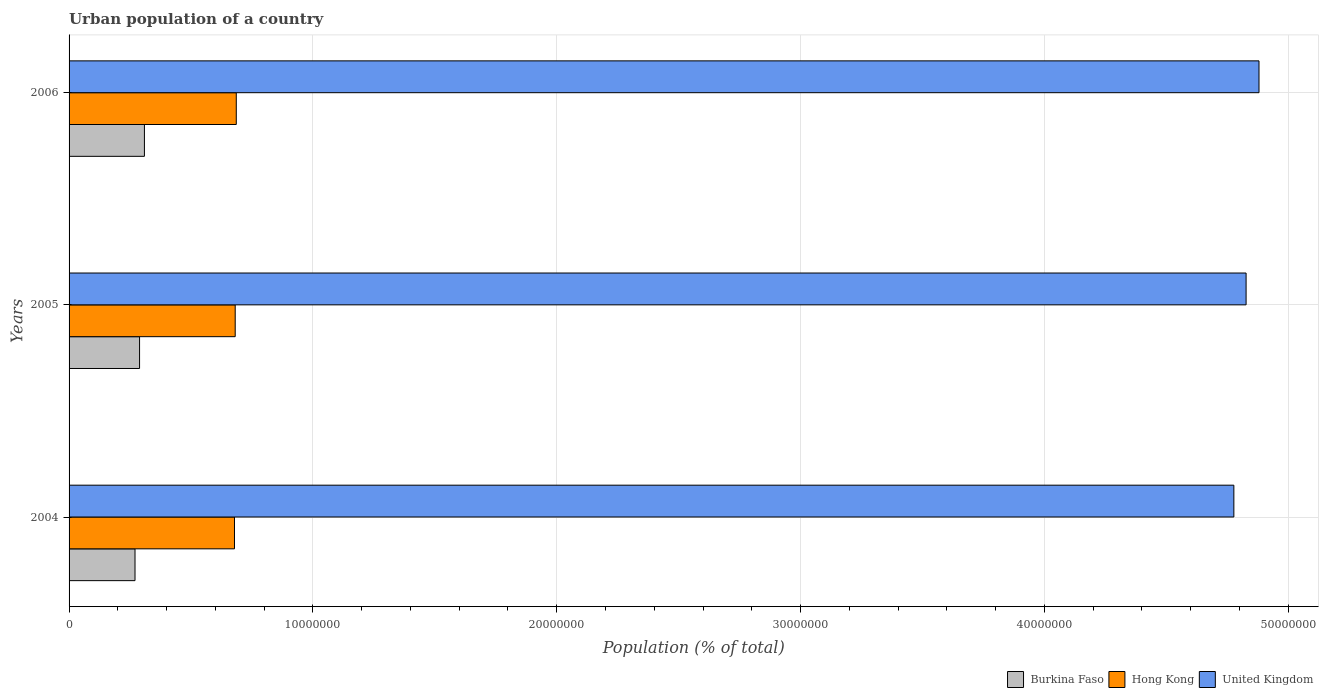How many bars are there on the 2nd tick from the top?
Ensure brevity in your answer.  3. What is the label of the 3rd group of bars from the top?
Offer a terse response. 2004. In how many cases, is the number of bars for a given year not equal to the number of legend labels?
Your response must be concise. 0. What is the urban population in United Kingdom in 2005?
Give a very brief answer. 4.83e+07. Across all years, what is the maximum urban population in Hong Kong?
Provide a short and direct response. 6.86e+06. Across all years, what is the minimum urban population in United Kingdom?
Keep it short and to the point. 4.78e+07. What is the total urban population in Hong Kong in the graph?
Provide a succinct answer. 2.05e+07. What is the difference between the urban population in Burkina Faso in 2005 and that in 2006?
Ensure brevity in your answer.  -2.00e+05. What is the difference between the urban population in United Kingdom in 2004 and the urban population in Burkina Faso in 2005?
Your answer should be compact. 4.49e+07. What is the average urban population in Hong Kong per year?
Your answer should be very brief. 6.82e+06. In the year 2004, what is the difference between the urban population in United Kingdom and urban population in Burkina Faso?
Make the answer very short. 4.51e+07. In how many years, is the urban population in Burkina Faso greater than 32000000 %?
Provide a short and direct response. 0. What is the ratio of the urban population in Hong Kong in 2005 to that in 2006?
Your answer should be compact. 0.99. Is the difference between the urban population in United Kingdom in 2004 and 2006 greater than the difference between the urban population in Burkina Faso in 2004 and 2006?
Provide a short and direct response. No. What is the difference between the highest and the second highest urban population in Burkina Faso?
Provide a short and direct response. 2.00e+05. What is the difference between the highest and the lowest urban population in Hong Kong?
Make the answer very short. 7.36e+04. In how many years, is the urban population in Burkina Faso greater than the average urban population in Burkina Faso taken over all years?
Give a very brief answer. 1. Is the sum of the urban population in Hong Kong in 2004 and 2005 greater than the maximum urban population in United Kingdom across all years?
Offer a terse response. No. What does the 3rd bar from the top in 2005 represents?
Ensure brevity in your answer.  Burkina Faso. What does the 1st bar from the bottom in 2004 represents?
Ensure brevity in your answer.  Burkina Faso. How many bars are there?
Provide a succinct answer. 9. What is the difference between two consecutive major ticks on the X-axis?
Ensure brevity in your answer.  1.00e+07. Are the values on the major ticks of X-axis written in scientific E-notation?
Keep it short and to the point. No. Does the graph contain grids?
Make the answer very short. Yes. How many legend labels are there?
Keep it short and to the point. 3. What is the title of the graph?
Give a very brief answer. Urban population of a country. Does "Iraq" appear as one of the legend labels in the graph?
Your answer should be very brief. No. What is the label or title of the X-axis?
Your answer should be compact. Population (% of total). What is the label or title of the Y-axis?
Offer a terse response. Years. What is the Population (% of total) of Burkina Faso in 2004?
Offer a very short reply. 2.70e+06. What is the Population (% of total) of Hong Kong in 2004?
Provide a short and direct response. 6.78e+06. What is the Population (% of total) in United Kingdom in 2004?
Offer a very short reply. 4.78e+07. What is the Population (% of total) of Burkina Faso in 2005?
Offer a very short reply. 2.89e+06. What is the Population (% of total) in Hong Kong in 2005?
Offer a terse response. 6.81e+06. What is the Population (% of total) of United Kingdom in 2005?
Make the answer very short. 4.83e+07. What is the Population (% of total) of Burkina Faso in 2006?
Your answer should be very brief. 3.09e+06. What is the Population (% of total) in Hong Kong in 2006?
Ensure brevity in your answer.  6.86e+06. What is the Population (% of total) of United Kingdom in 2006?
Provide a short and direct response. 4.88e+07. Across all years, what is the maximum Population (% of total) of Burkina Faso?
Provide a short and direct response. 3.09e+06. Across all years, what is the maximum Population (% of total) in Hong Kong?
Offer a terse response. 6.86e+06. Across all years, what is the maximum Population (% of total) of United Kingdom?
Offer a very short reply. 4.88e+07. Across all years, what is the minimum Population (% of total) of Burkina Faso?
Make the answer very short. 2.70e+06. Across all years, what is the minimum Population (% of total) in Hong Kong?
Make the answer very short. 6.78e+06. Across all years, what is the minimum Population (% of total) of United Kingdom?
Make the answer very short. 4.78e+07. What is the total Population (% of total) in Burkina Faso in the graph?
Offer a very short reply. 8.69e+06. What is the total Population (% of total) in Hong Kong in the graph?
Your answer should be very brief. 2.05e+07. What is the total Population (% of total) of United Kingdom in the graph?
Your answer should be compact. 1.45e+08. What is the difference between the Population (% of total) in Burkina Faso in 2004 and that in 2005?
Provide a short and direct response. -1.86e+05. What is the difference between the Population (% of total) in Hong Kong in 2004 and that in 2005?
Ensure brevity in your answer.  -2.97e+04. What is the difference between the Population (% of total) of United Kingdom in 2004 and that in 2005?
Your answer should be very brief. -5.02e+05. What is the difference between the Population (% of total) in Burkina Faso in 2004 and that in 2006?
Your answer should be compact. -3.86e+05. What is the difference between the Population (% of total) in Hong Kong in 2004 and that in 2006?
Your answer should be compact. -7.36e+04. What is the difference between the Population (% of total) in United Kingdom in 2004 and that in 2006?
Provide a succinct answer. -1.03e+06. What is the difference between the Population (% of total) of Burkina Faso in 2005 and that in 2006?
Provide a succinct answer. -2.00e+05. What is the difference between the Population (% of total) in Hong Kong in 2005 and that in 2006?
Give a very brief answer. -4.39e+04. What is the difference between the Population (% of total) in United Kingdom in 2005 and that in 2006?
Provide a succinct answer. -5.29e+05. What is the difference between the Population (% of total) of Burkina Faso in 2004 and the Population (% of total) of Hong Kong in 2005?
Your response must be concise. -4.11e+06. What is the difference between the Population (% of total) in Burkina Faso in 2004 and the Population (% of total) in United Kingdom in 2005?
Provide a short and direct response. -4.56e+07. What is the difference between the Population (% of total) in Hong Kong in 2004 and the Population (% of total) in United Kingdom in 2005?
Keep it short and to the point. -4.15e+07. What is the difference between the Population (% of total) of Burkina Faso in 2004 and the Population (% of total) of Hong Kong in 2006?
Provide a succinct answer. -4.15e+06. What is the difference between the Population (% of total) in Burkina Faso in 2004 and the Population (% of total) in United Kingdom in 2006?
Give a very brief answer. -4.61e+07. What is the difference between the Population (% of total) in Hong Kong in 2004 and the Population (% of total) in United Kingdom in 2006?
Your response must be concise. -4.20e+07. What is the difference between the Population (% of total) of Burkina Faso in 2005 and the Population (% of total) of Hong Kong in 2006?
Provide a short and direct response. -3.97e+06. What is the difference between the Population (% of total) of Burkina Faso in 2005 and the Population (% of total) of United Kingdom in 2006?
Your response must be concise. -4.59e+07. What is the difference between the Population (% of total) of Hong Kong in 2005 and the Population (% of total) of United Kingdom in 2006?
Your response must be concise. -4.20e+07. What is the average Population (% of total) in Burkina Faso per year?
Offer a very short reply. 2.90e+06. What is the average Population (% of total) of Hong Kong per year?
Make the answer very short. 6.82e+06. What is the average Population (% of total) in United Kingdom per year?
Provide a succinct answer. 4.83e+07. In the year 2004, what is the difference between the Population (% of total) in Burkina Faso and Population (% of total) in Hong Kong?
Give a very brief answer. -4.08e+06. In the year 2004, what is the difference between the Population (% of total) of Burkina Faso and Population (% of total) of United Kingdom?
Offer a terse response. -4.51e+07. In the year 2004, what is the difference between the Population (% of total) of Hong Kong and Population (% of total) of United Kingdom?
Provide a succinct answer. -4.10e+07. In the year 2005, what is the difference between the Population (% of total) in Burkina Faso and Population (% of total) in Hong Kong?
Your answer should be very brief. -3.92e+06. In the year 2005, what is the difference between the Population (% of total) of Burkina Faso and Population (% of total) of United Kingdom?
Your answer should be very brief. -4.54e+07. In the year 2005, what is the difference between the Population (% of total) of Hong Kong and Population (% of total) of United Kingdom?
Provide a short and direct response. -4.15e+07. In the year 2006, what is the difference between the Population (% of total) of Burkina Faso and Population (% of total) of Hong Kong?
Your answer should be compact. -3.77e+06. In the year 2006, what is the difference between the Population (% of total) in Burkina Faso and Population (% of total) in United Kingdom?
Give a very brief answer. -4.57e+07. In the year 2006, what is the difference between the Population (% of total) in Hong Kong and Population (% of total) in United Kingdom?
Offer a terse response. -4.19e+07. What is the ratio of the Population (% of total) in Burkina Faso in 2004 to that in 2005?
Ensure brevity in your answer.  0.94. What is the ratio of the Population (% of total) in United Kingdom in 2004 to that in 2005?
Provide a succinct answer. 0.99. What is the ratio of the Population (% of total) in Burkina Faso in 2004 to that in 2006?
Provide a succinct answer. 0.88. What is the ratio of the Population (% of total) of Hong Kong in 2004 to that in 2006?
Your answer should be compact. 0.99. What is the ratio of the Population (% of total) in United Kingdom in 2004 to that in 2006?
Your answer should be compact. 0.98. What is the ratio of the Population (% of total) in Burkina Faso in 2005 to that in 2006?
Your answer should be very brief. 0.94. What is the ratio of the Population (% of total) of Hong Kong in 2005 to that in 2006?
Your answer should be very brief. 0.99. What is the ratio of the Population (% of total) of United Kingdom in 2005 to that in 2006?
Keep it short and to the point. 0.99. What is the difference between the highest and the second highest Population (% of total) in Burkina Faso?
Your answer should be very brief. 2.00e+05. What is the difference between the highest and the second highest Population (% of total) in Hong Kong?
Your answer should be very brief. 4.39e+04. What is the difference between the highest and the second highest Population (% of total) of United Kingdom?
Make the answer very short. 5.29e+05. What is the difference between the highest and the lowest Population (% of total) of Burkina Faso?
Your response must be concise. 3.86e+05. What is the difference between the highest and the lowest Population (% of total) of Hong Kong?
Offer a terse response. 7.36e+04. What is the difference between the highest and the lowest Population (% of total) in United Kingdom?
Provide a succinct answer. 1.03e+06. 